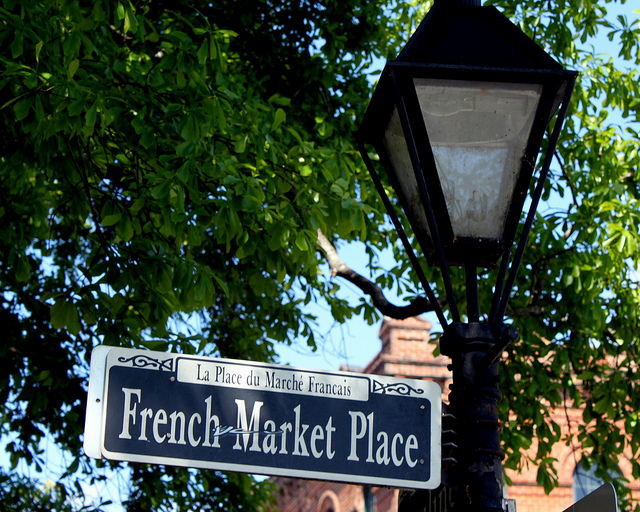Read and extract the text from this image. La Place French Market Place Francis Marche du 